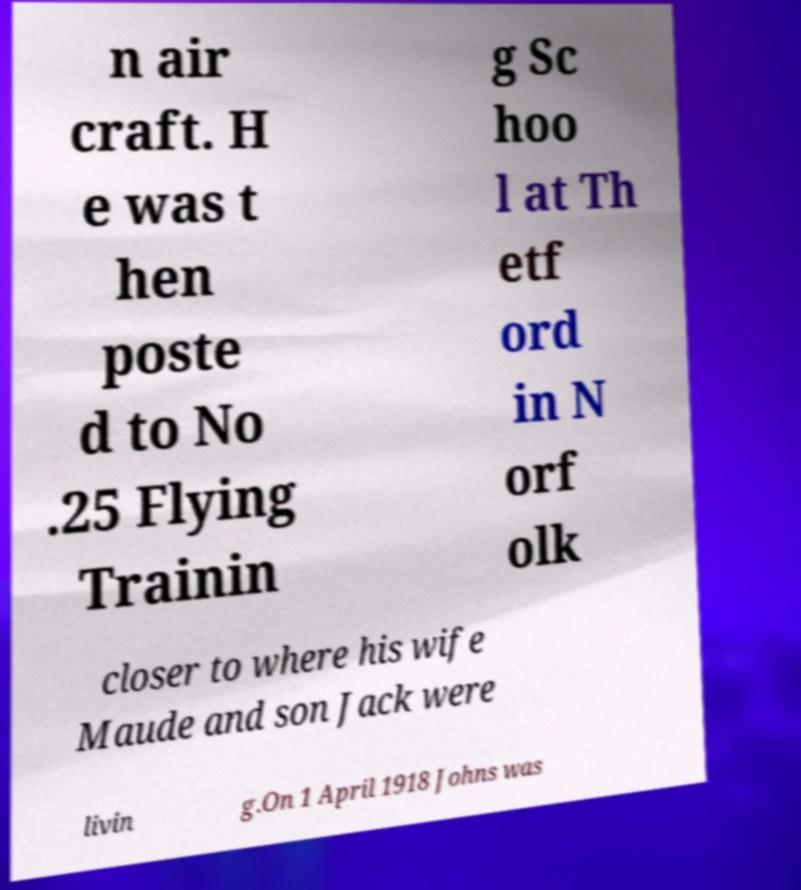Can you accurately transcribe the text from the provided image for me? n air craft. H e was t hen poste d to No .25 Flying Trainin g Sc hoo l at Th etf ord in N orf olk closer to where his wife Maude and son Jack were livin g.On 1 April 1918 Johns was 